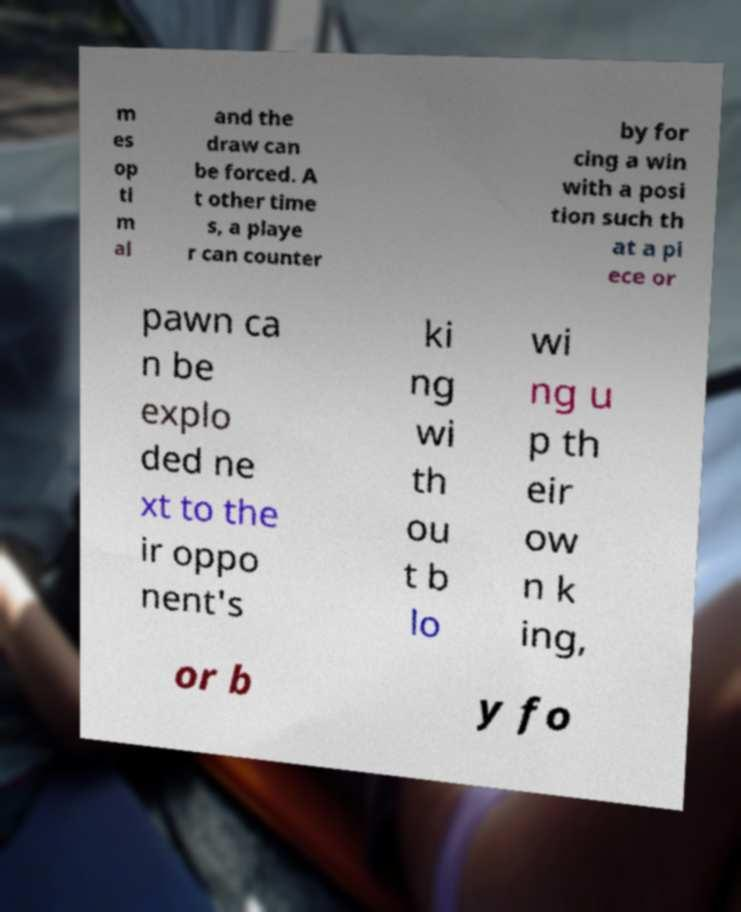Can you accurately transcribe the text from the provided image for me? m es op ti m al and the draw can be forced. A t other time s, a playe r can counter by for cing a win with a posi tion such th at a pi ece or pawn ca n be explo ded ne xt to the ir oppo nent's ki ng wi th ou t b lo wi ng u p th eir ow n k ing, or b y fo 